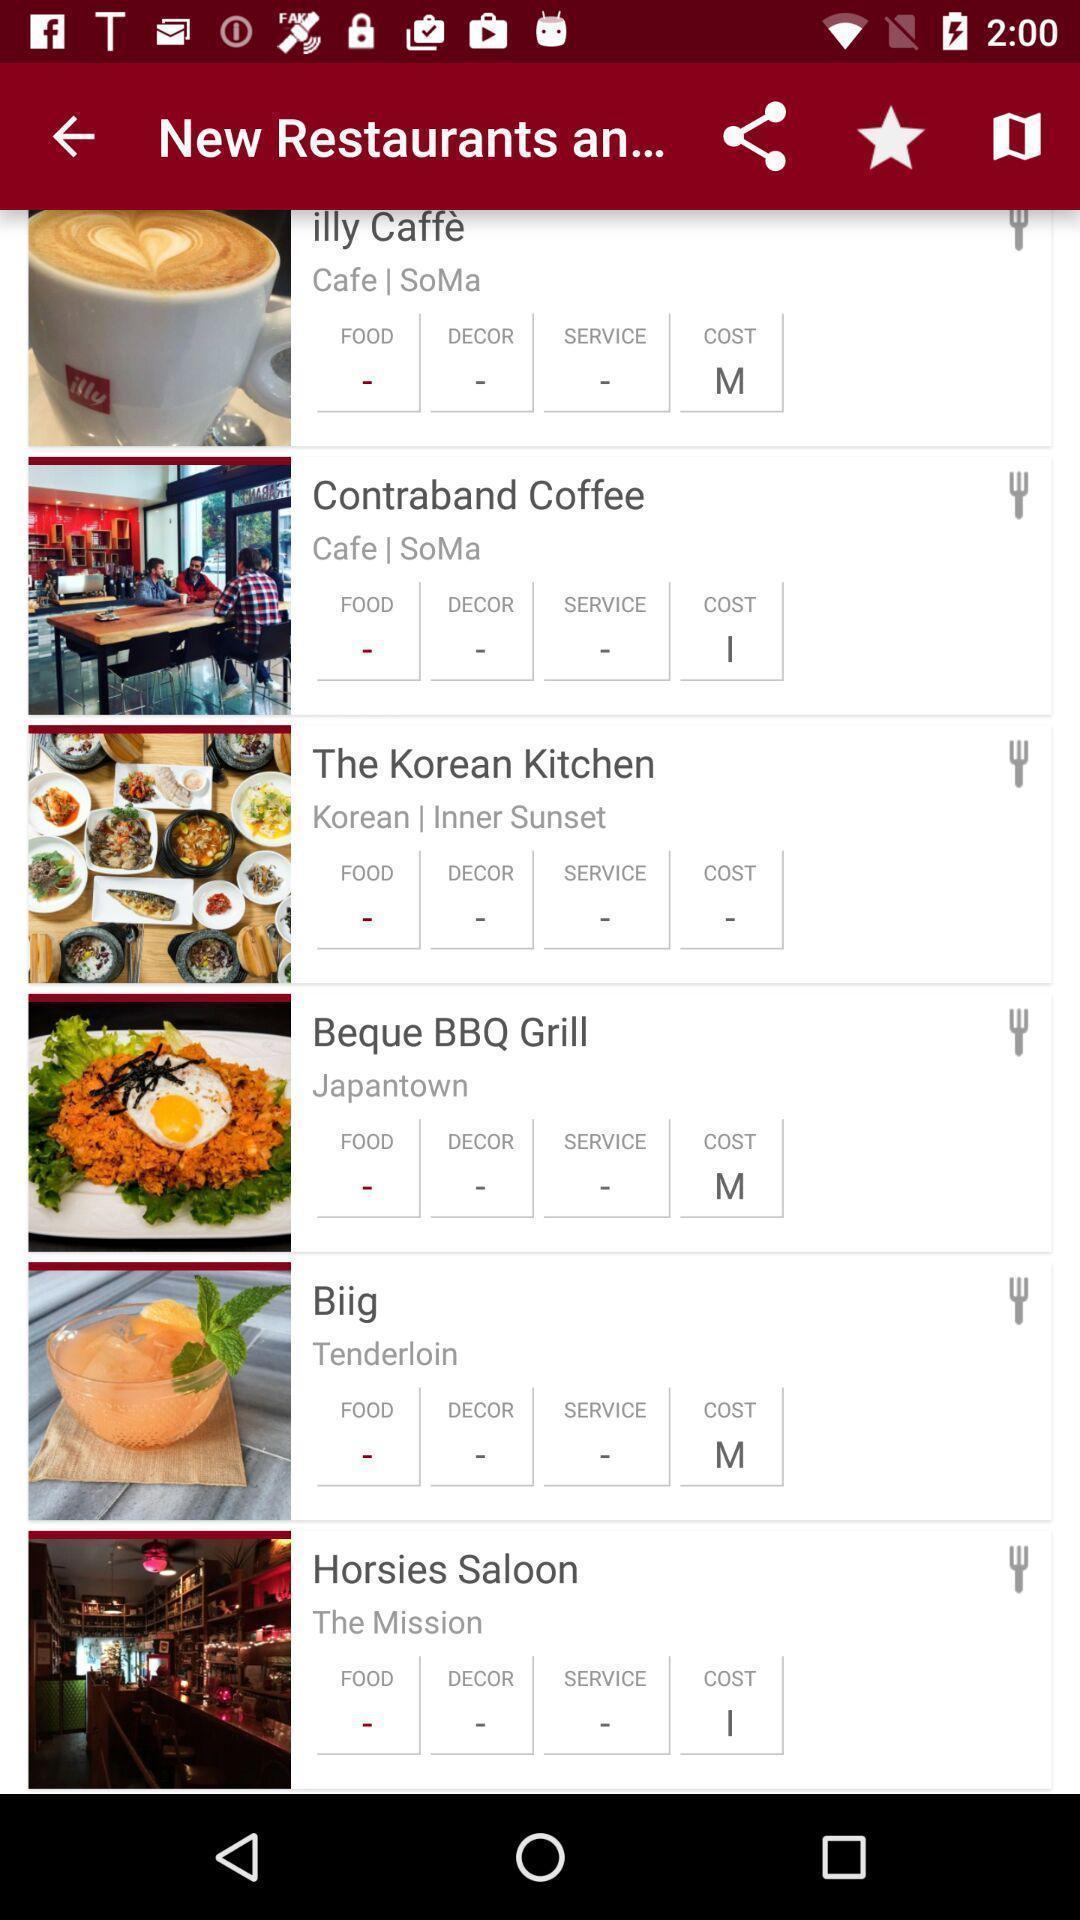Describe the key features of this screenshot. Screen shows list of new restaurants. 